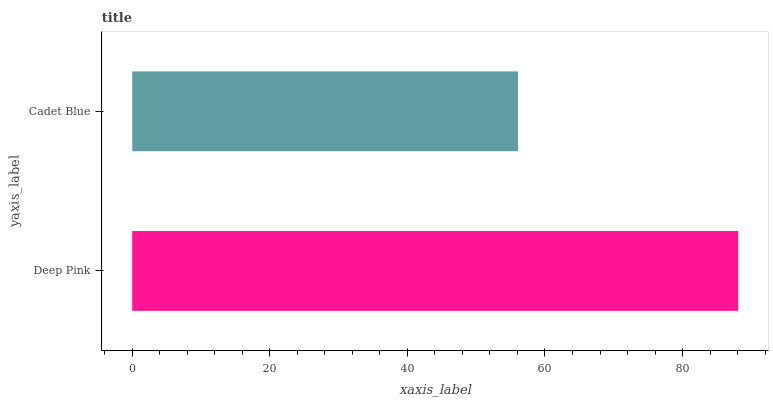Is Cadet Blue the minimum?
Answer yes or no. Yes. Is Deep Pink the maximum?
Answer yes or no. Yes. Is Cadet Blue the maximum?
Answer yes or no. No. Is Deep Pink greater than Cadet Blue?
Answer yes or no. Yes. Is Cadet Blue less than Deep Pink?
Answer yes or no. Yes. Is Cadet Blue greater than Deep Pink?
Answer yes or no. No. Is Deep Pink less than Cadet Blue?
Answer yes or no. No. Is Deep Pink the high median?
Answer yes or no. Yes. Is Cadet Blue the low median?
Answer yes or no. Yes. Is Cadet Blue the high median?
Answer yes or no. No. Is Deep Pink the low median?
Answer yes or no. No. 